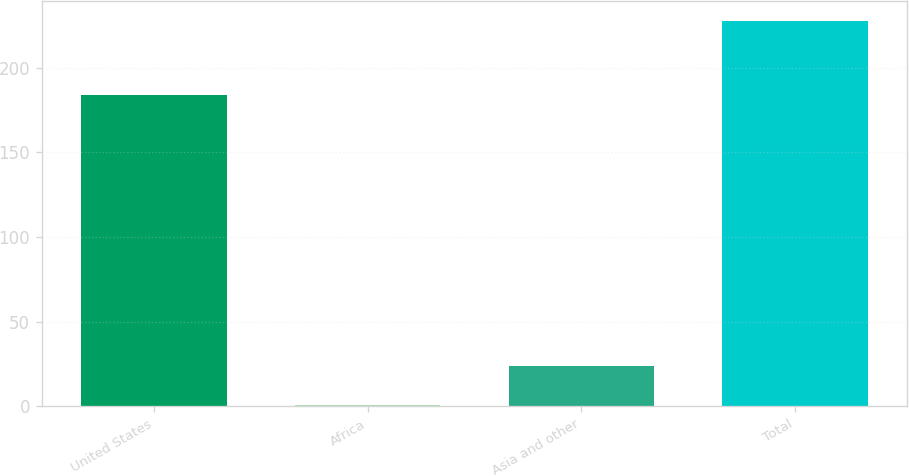Convert chart. <chart><loc_0><loc_0><loc_500><loc_500><bar_chart><fcel>United States<fcel>Africa<fcel>Asia and other<fcel>Total<nl><fcel>184<fcel>1<fcel>23.7<fcel>228<nl></chart> 